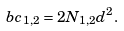Convert formula to latex. <formula><loc_0><loc_0><loc_500><loc_500>b c _ { 1 , 2 } = 2 N _ { 1 , 2 } d ^ { 2 } .</formula> 